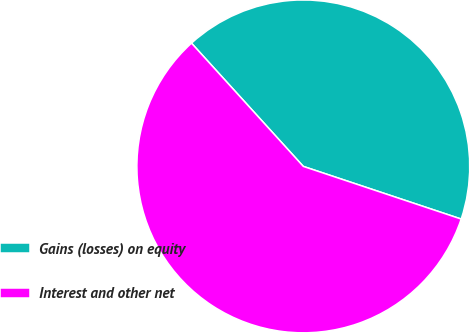Convert chart to OTSL. <chart><loc_0><loc_0><loc_500><loc_500><pie_chart><fcel>Gains (losses) on equity<fcel>Interest and other net<nl><fcel>41.85%<fcel>58.15%<nl></chart> 